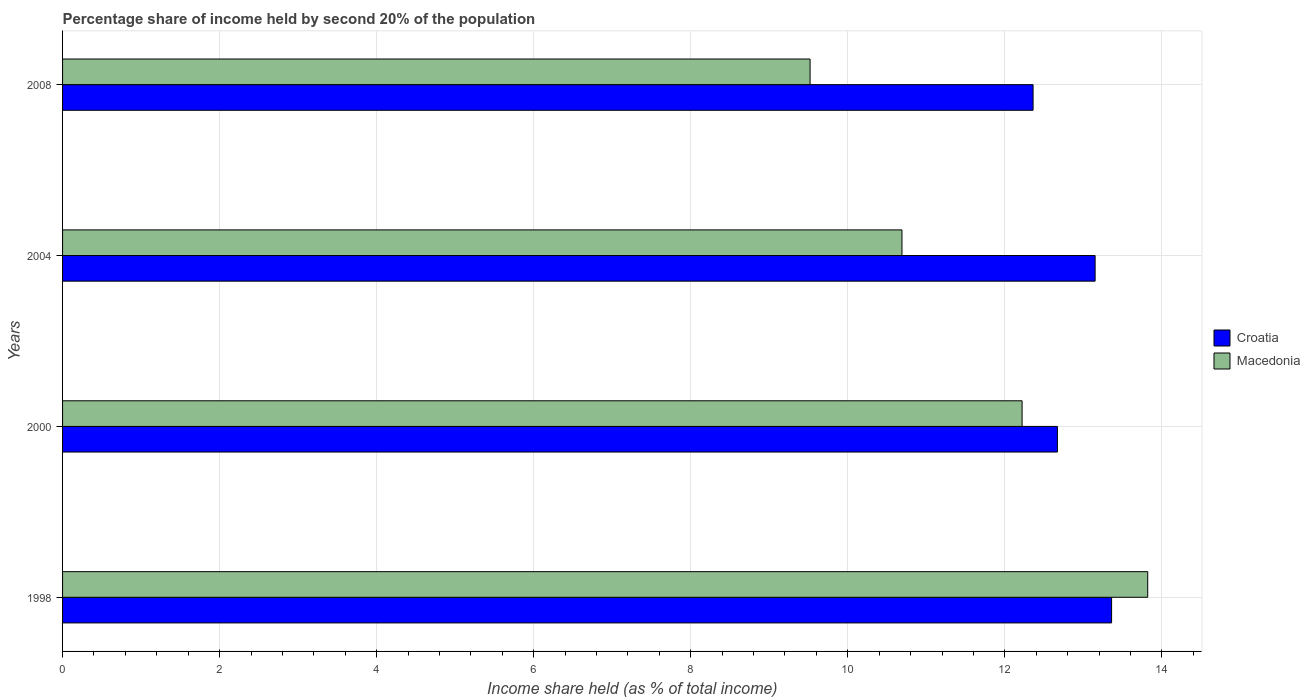How many different coloured bars are there?
Ensure brevity in your answer.  2. Are the number of bars on each tick of the Y-axis equal?
Your response must be concise. Yes. How many bars are there on the 1st tick from the top?
Provide a succinct answer. 2. What is the label of the 3rd group of bars from the top?
Your response must be concise. 2000. What is the share of income held by second 20% of the population in Croatia in 1998?
Give a very brief answer. 13.36. Across all years, what is the maximum share of income held by second 20% of the population in Croatia?
Provide a short and direct response. 13.36. Across all years, what is the minimum share of income held by second 20% of the population in Croatia?
Ensure brevity in your answer.  12.36. What is the total share of income held by second 20% of the population in Croatia in the graph?
Ensure brevity in your answer.  51.54. What is the difference between the share of income held by second 20% of the population in Macedonia in 1998 and that in 2008?
Make the answer very short. 4.3. What is the difference between the share of income held by second 20% of the population in Macedonia in 2004 and the share of income held by second 20% of the population in Croatia in 2000?
Your answer should be very brief. -1.98. What is the average share of income held by second 20% of the population in Croatia per year?
Provide a succinct answer. 12.88. In the year 2000, what is the difference between the share of income held by second 20% of the population in Macedonia and share of income held by second 20% of the population in Croatia?
Give a very brief answer. -0.45. In how many years, is the share of income held by second 20% of the population in Macedonia greater than 6 %?
Keep it short and to the point. 4. What is the ratio of the share of income held by second 20% of the population in Croatia in 2004 to that in 2008?
Offer a very short reply. 1.06. Is the difference between the share of income held by second 20% of the population in Macedonia in 1998 and 2008 greater than the difference between the share of income held by second 20% of the population in Croatia in 1998 and 2008?
Ensure brevity in your answer.  Yes. What is the difference between the highest and the second highest share of income held by second 20% of the population in Croatia?
Keep it short and to the point. 0.21. What is the difference between the highest and the lowest share of income held by second 20% of the population in Macedonia?
Provide a short and direct response. 4.3. In how many years, is the share of income held by second 20% of the population in Macedonia greater than the average share of income held by second 20% of the population in Macedonia taken over all years?
Offer a very short reply. 2. What does the 1st bar from the top in 2008 represents?
Your answer should be compact. Macedonia. What does the 2nd bar from the bottom in 1998 represents?
Your answer should be very brief. Macedonia. What is the difference between two consecutive major ticks on the X-axis?
Your response must be concise. 2. Are the values on the major ticks of X-axis written in scientific E-notation?
Your answer should be very brief. No. Does the graph contain grids?
Keep it short and to the point. Yes. Where does the legend appear in the graph?
Make the answer very short. Center right. How many legend labels are there?
Ensure brevity in your answer.  2. What is the title of the graph?
Provide a short and direct response. Percentage share of income held by second 20% of the population. What is the label or title of the X-axis?
Provide a short and direct response. Income share held (as % of total income). What is the label or title of the Y-axis?
Offer a terse response. Years. What is the Income share held (as % of total income) of Croatia in 1998?
Your answer should be compact. 13.36. What is the Income share held (as % of total income) of Macedonia in 1998?
Keep it short and to the point. 13.82. What is the Income share held (as % of total income) of Croatia in 2000?
Provide a succinct answer. 12.67. What is the Income share held (as % of total income) of Macedonia in 2000?
Your response must be concise. 12.22. What is the Income share held (as % of total income) in Croatia in 2004?
Your answer should be very brief. 13.15. What is the Income share held (as % of total income) of Macedonia in 2004?
Your response must be concise. 10.69. What is the Income share held (as % of total income) of Croatia in 2008?
Offer a terse response. 12.36. What is the Income share held (as % of total income) in Macedonia in 2008?
Provide a succinct answer. 9.52. Across all years, what is the maximum Income share held (as % of total income) in Croatia?
Ensure brevity in your answer.  13.36. Across all years, what is the maximum Income share held (as % of total income) of Macedonia?
Your answer should be very brief. 13.82. Across all years, what is the minimum Income share held (as % of total income) in Croatia?
Provide a succinct answer. 12.36. Across all years, what is the minimum Income share held (as % of total income) in Macedonia?
Your response must be concise. 9.52. What is the total Income share held (as % of total income) in Croatia in the graph?
Your response must be concise. 51.54. What is the total Income share held (as % of total income) of Macedonia in the graph?
Your response must be concise. 46.25. What is the difference between the Income share held (as % of total income) of Croatia in 1998 and that in 2000?
Ensure brevity in your answer.  0.69. What is the difference between the Income share held (as % of total income) of Macedonia in 1998 and that in 2000?
Give a very brief answer. 1.6. What is the difference between the Income share held (as % of total income) in Croatia in 1998 and that in 2004?
Ensure brevity in your answer.  0.21. What is the difference between the Income share held (as % of total income) of Macedonia in 1998 and that in 2004?
Ensure brevity in your answer.  3.13. What is the difference between the Income share held (as % of total income) of Macedonia in 1998 and that in 2008?
Give a very brief answer. 4.3. What is the difference between the Income share held (as % of total income) in Croatia in 2000 and that in 2004?
Your answer should be compact. -0.48. What is the difference between the Income share held (as % of total income) in Macedonia in 2000 and that in 2004?
Your answer should be very brief. 1.53. What is the difference between the Income share held (as % of total income) in Croatia in 2000 and that in 2008?
Your answer should be compact. 0.31. What is the difference between the Income share held (as % of total income) of Macedonia in 2000 and that in 2008?
Offer a terse response. 2.7. What is the difference between the Income share held (as % of total income) in Croatia in 2004 and that in 2008?
Keep it short and to the point. 0.79. What is the difference between the Income share held (as % of total income) of Macedonia in 2004 and that in 2008?
Offer a terse response. 1.17. What is the difference between the Income share held (as % of total income) of Croatia in 1998 and the Income share held (as % of total income) of Macedonia in 2000?
Your answer should be very brief. 1.14. What is the difference between the Income share held (as % of total income) of Croatia in 1998 and the Income share held (as % of total income) of Macedonia in 2004?
Offer a very short reply. 2.67. What is the difference between the Income share held (as % of total income) in Croatia in 1998 and the Income share held (as % of total income) in Macedonia in 2008?
Give a very brief answer. 3.84. What is the difference between the Income share held (as % of total income) in Croatia in 2000 and the Income share held (as % of total income) in Macedonia in 2004?
Ensure brevity in your answer.  1.98. What is the difference between the Income share held (as % of total income) of Croatia in 2000 and the Income share held (as % of total income) of Macedonia in 2008?
Offer a terse response. 3.15. What is the difference between the Income share held (as % of total income) of Croatia in 2004 and the Income share held (as % of total income) of Macedonia in 2008?
Provide a succinct answer. 3.63. What is the average Income share held (as % of total income) of Croatia per year?
Provide a short and direct response. 12.88. What is the average Income share held (as % of total income) of Macedonia per year?
Provide a succinct answer. 11.56. In the year 1998, what is the difference between the Income share held (as % of total income) of Croatia and Income share held (as % of total income) of Macedonia?
Keep it short and to the point. -0.46. In the year 2000, what is the difference between the Income share held (as % of total income) in Croatia and Income share held (as % of total income) in Macedonia?
Ensure brevity in your answer.  0.45. In the year 2004, what is the difference between the Income share held (as % of total income) of Croatia and Income share held (as % of total income) of Macedonia?
Give a very brief answer. 2.46. In the year 2008, what is the difference between the Income share held (as % of total income) in Croatia and Income share held (as % of total income) in Macedonia?
Provide a short and direct response. 2.84. What is the ratio of the Income share held (as % of total income) in Croatia in 1998 to that in 2000?
Offer a very short reply. 1.05. What is the ratio of the Income share held (as % of total income) in Macedonia in 1998 to that in 2000?
Keep it short and to the point. 1.13. What is the ratio of the Income share held (as % of total income) of Macedonia in 1998 to that in 2004?
Offer a very short reply. 1.29. What is the ratio of the Income share held (as % of total income) of Croatia in 1998 to that in 2008?
Make the answer very short. 1.08. What is the ratio of the Income share held (as % of total income) of Macedonia in 1998 to that in 2008?
Give a very brief answer. 1.45. What is the ratio of the Income share held (as % of total income) in Croatia in 2000 to that in 2004?
Your response must be concise. 0.96. What is the ratio of the Income share held (as % of total income) in Macedonia in 2000 to that in 2004?
Your response must be concise. 1.14. What is the ratio of the Income share held (as % of total income) of Croatia in 2000 to that in 2008?
Make the answer very short. 1.03. What is the ratio of the Income share held (as % of total income) of Macedonia in 2000 to that in 2008?
Your response must be concise. 1.28. What is the ratio of the Income share held (as % of total income) of Croatia in 2004 to that in 2008?
Offer a terse response. 1.06. What is the ratio of the Income share held (as % of total income) of Macedonia in 2004 to that in 2008?
Provide a short and direct response. 1.12. What is the difference between the highest and the second highest Income share held (as % of total income) of Croatia?
Give a very brief answer. 0.21. 